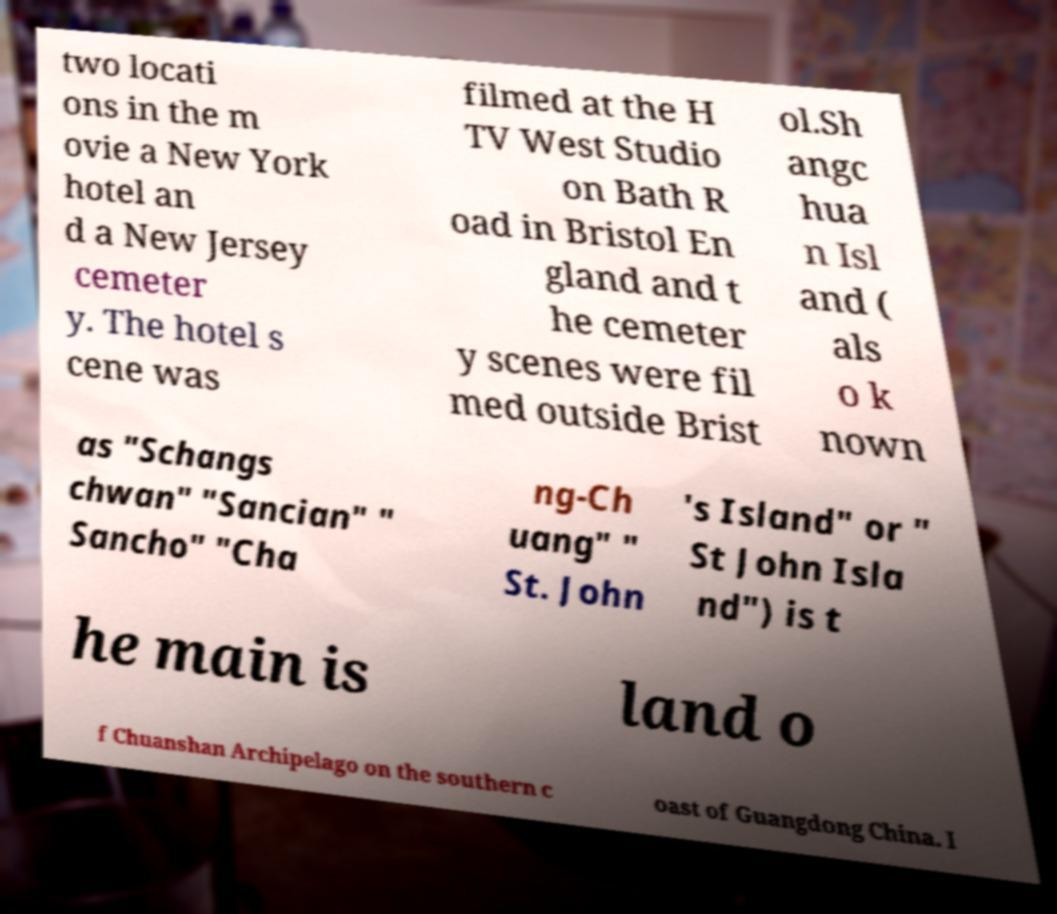Can you accurately transcribe the text from the provided image for me? two locati ons in the m ovie a New York hotel an d a New Jersey cemeter y. The hotel s cene was filmed at the H TV West Studio on Bath R oad in Bristol En gland and t he cemeter y scenes were fil med outside Brist ol.Sh angc hua n Isl and ( als o k nown as "Schangs chwan" "Sancian" " Sancho" "Cha ng-Ch uang" " St. John 's Island" or " St John Isla nd") is t he main is land o f Chuanshan Archipelago on the southern c oast of Guangdong China. I 